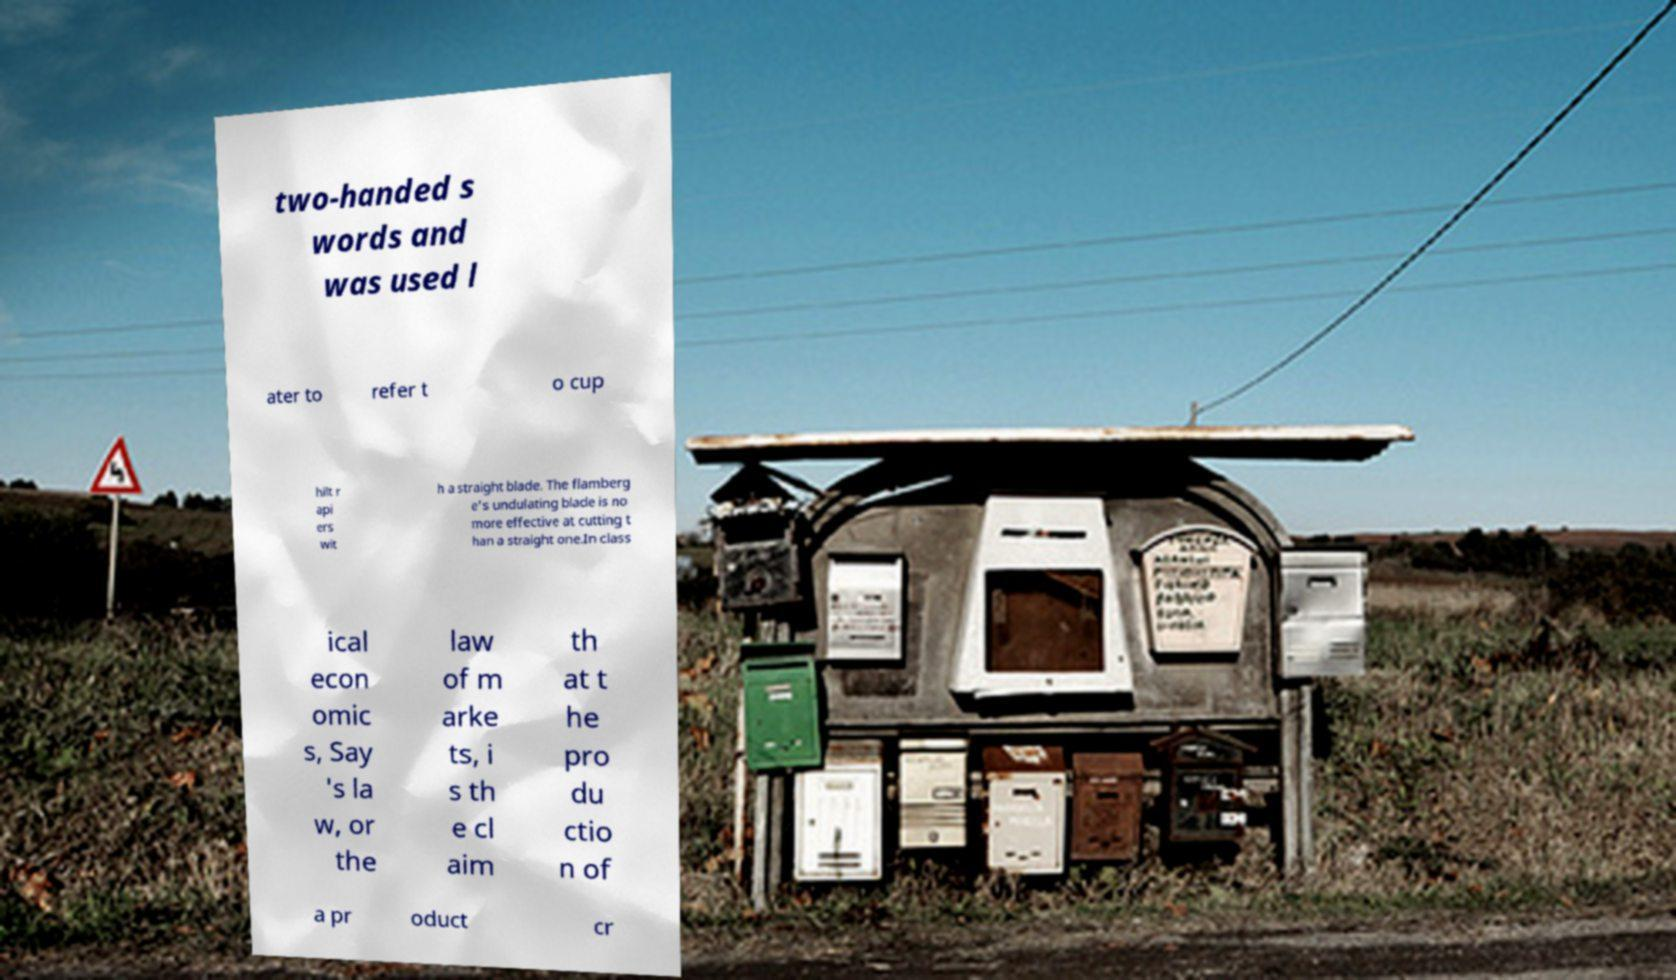Please read and relay the text visible in this image. What does it say? two-handed s words and was used l ater to refer t o cup hilt r api ers wit h a straight blade. The flamberg e's undulating blade is no more effective at cutting t han a straight one.In class ical econ omic s, Say 's la w, or the law of m arke ts, i s th e cl aim th at t he pro du ctio n of a pr oduct cr 